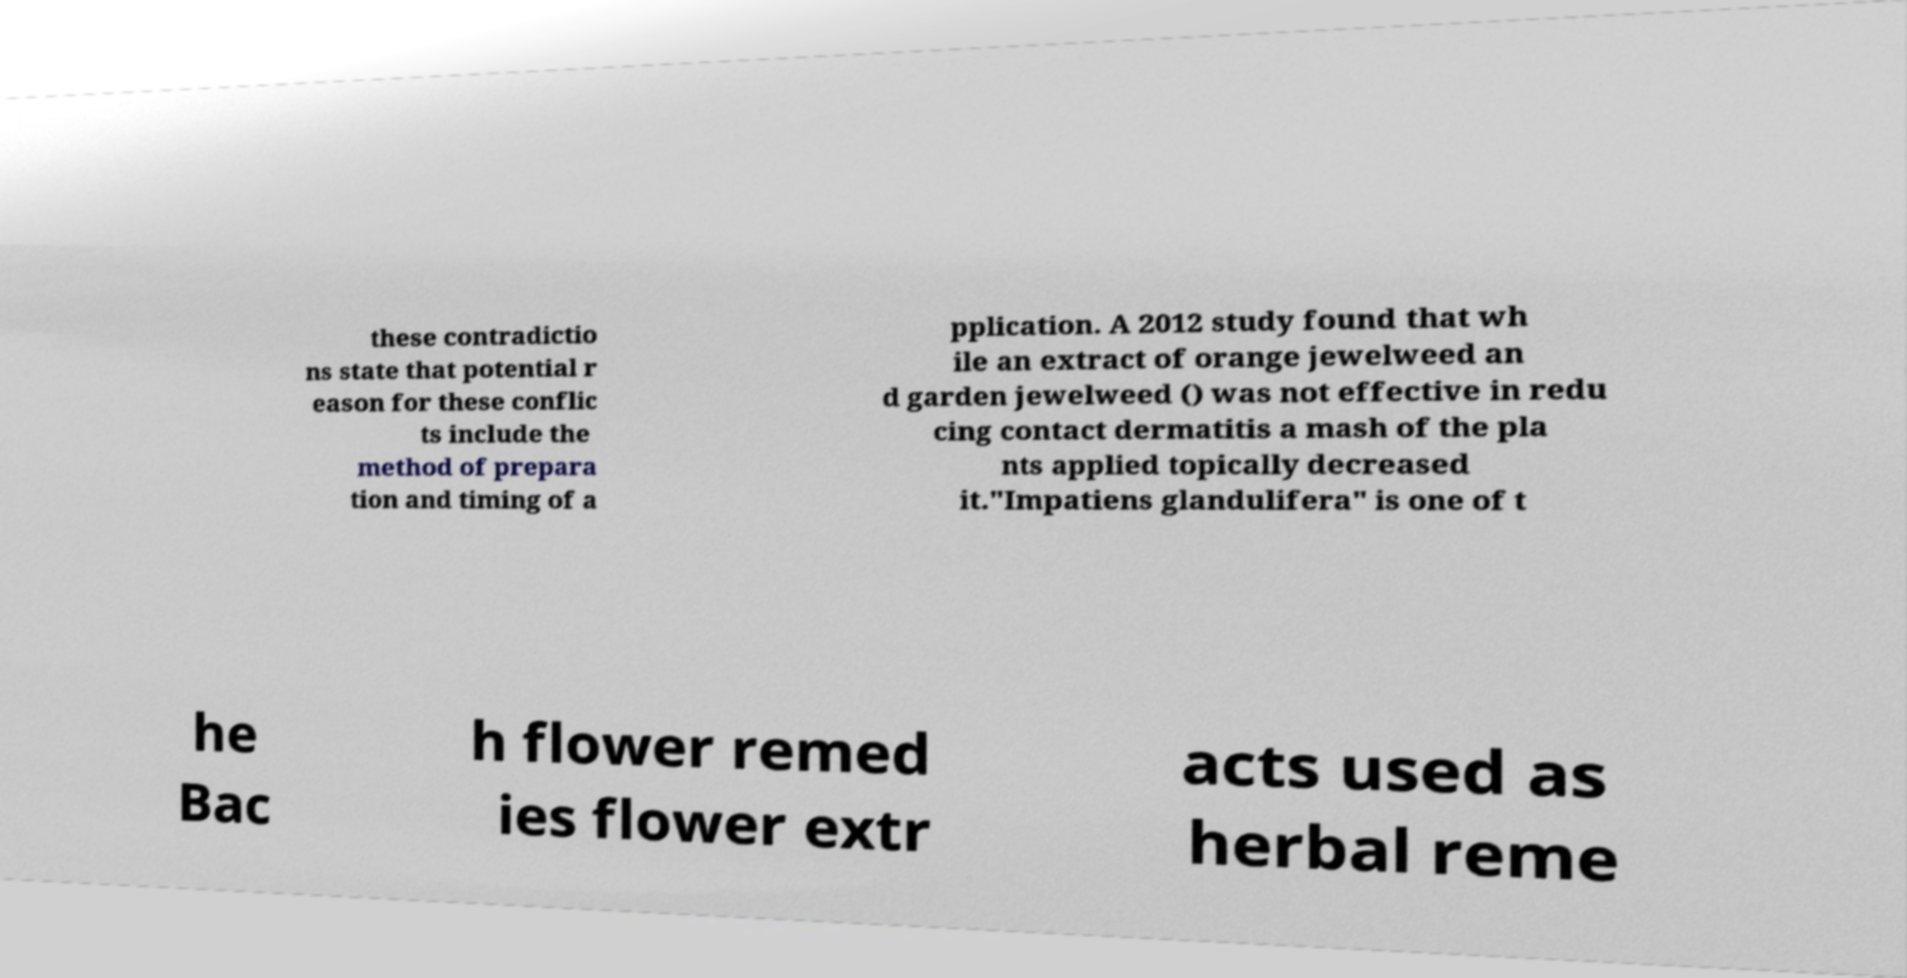There's text embedded in this image that I need extracted. Can you transcribe it verbatim? these contradictio ns state that potential r eason for these conflic ts include the method of prepara tion and timing of a pplication. A 2012 study found that wh ile an extract of orange jewelweed an d garden jewelweed () was not effective in redu cing contact dermatitis a mash of the pla nts applied topically decreased it."Impatiens glandulifera" is one of t he Bac h flower remed ies flower extr acts used as herbal reme 